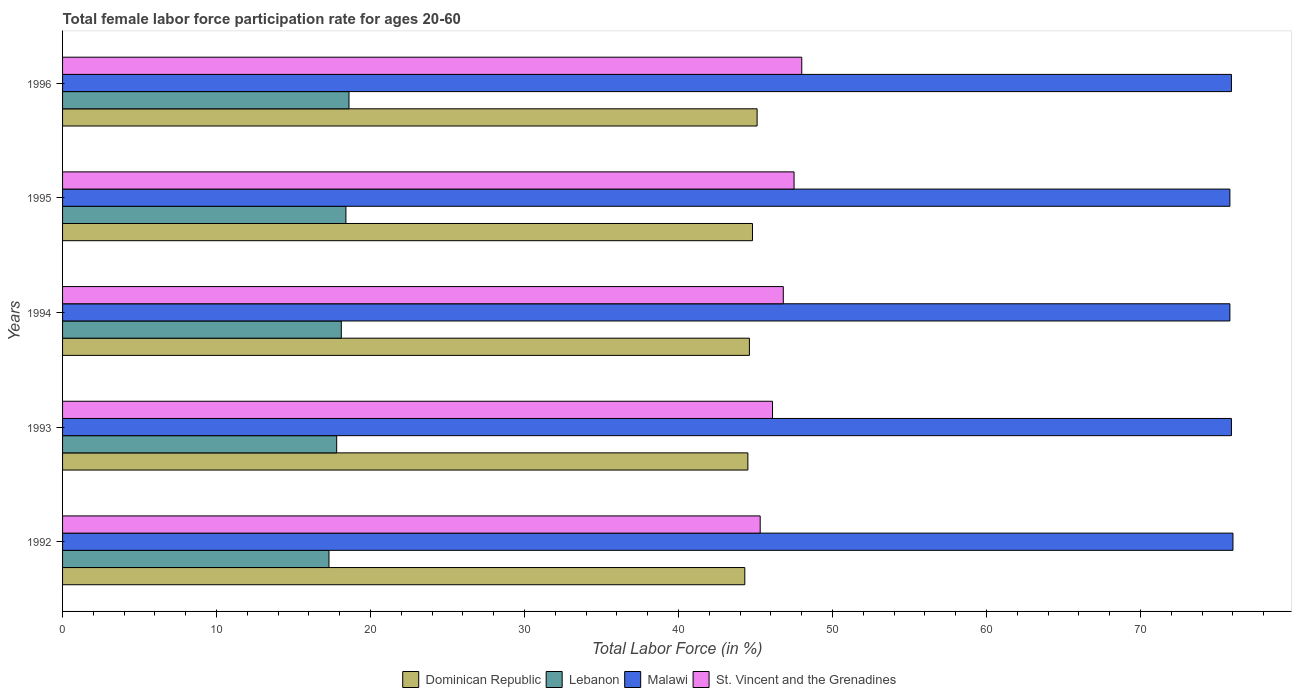How many different coloured bars are there?
Make the answer very short. 4. Are the number of bars per tick equal to the number of legend labels?
Your response must be concise. Yes. Are the number of bars on each tick of the Y-axis equal?
Provide a succinct answer. Yes. What is the label of the 5th group of bars from the top?
Your response must be concise. 1992. In how many cases, is the number of bars for a given year not equal to the number of legend labels?
Ensure brevity in your answer.  0. What is the female labor force participation rate in Dominican Republic in 1992?
Provide a succinct answer. 44.3. Across all years, what is the maximum female labor force participation rate in St. Vincent and the Grenadines?
Offer a terse response. 48. Across all years, what is the minimum female labor force participation rate in Dominican Republic?
Your response must be concise. 44.3. In which year was the female labor force participation rate in Malawi maximum?
Your answer should be very brief. 1992. In which year was the female labor force participation rate in St. Vincent and the Grenadines minimum?
Your answer should be very brief. 1992. What is the total female labor force participation rate in St. Vincent and the Grenadines in the graph?
Give a very brief answer. 233.7. What is the difference between the female labor force participation rate in Malawi in 1993 and that in 1995?
Your answer should be compact. 0.1. What is the difference between the female labor force participation rate in Malawi in 1993 and the female labor force participation rate in Lebanon in 1996?
Ensure brevity in your answer.  57.3. What is the average female labor force participation rate in Dominican Republic per year?
Ensure brevity in your answer.  44.66. In the year 1992, what is the difference between the female labor force participation rate in Lebanon and female labor force participation rate in St. Vincent and the Grenadines?
Ensure brevity in your answer.  -28. What is the ratio of the female labor force participation rate in Dominican Republic in 1994 to that in 1996?
Your answer should be very brief. 0.99. Is the female labor force participation rate in Dominican Republic in 1993 less than that in 1994?
Provide a succinct answer. Yes. What is the difference between the highest and the second highest female labor force participation rate in St. Vincent and the Grenadines?
Provide a succinct answer. 0.5. What is the difference between the highest and the lowest female labor force participation rate in Malawi?
Your answer should be very brief. 0.2. Is the sum of the female labor force participation rate in St. Vincent and the Grenadines in 1994 and 1995 greater than the maximum female labor force participation rate in Malawi across all years?
Give a very brief answer. Yes. Is it the case that in every year, the sum of the female labor force participation rate in St. Vincent and the Grenadines and female labor force participation rate in Dominican Republic is greater than the sum of female labor force participation rate in Malawi and female labor force participation rate in Lebanon?
Provide a short and direct response. No. What does the 1st bar from the top in 1994 represents?
Offer a very short reply. St. Vincent and the Grenadines. What does the 4th bar from the bottom in 1992 represents?
Make the answer very short. St. Vincent and the Grenadines. Is it the case that in every year, the sum of the female labor force participation rate in Dominican Republic and female labor force participation rate in Lebanon is greater than the female labor force participation rate in Malawi?
Your answer should be compact. No. How many bars are there?
Give a very brief answer. 20. Does the graph contain grids?
Provide a short and direct response. No. How are the legend labels stacked?
Your response must be concise. Horizontal. What is the title of the graph?
Ensure brevity in your answer.  Total female labor force participation rate for ages 20-60. Does "Ethiopia" appear as one of the legend labels in the graph?
Your answer should be compact. No. What is the label or title of the Y-axis?
Ensure brevity in your answer.  Years. What is the Total Labor Force (in %) of Dominican Republic in 1992?
Provide a short and direct response. 44.3. What is the Total Labor Force (in %) in Lebanon in 1992?
Your response must be concise. 17.3. What is the Total Labor Force (in %) of St. Vincent and the Grenadines in 1992?
Keep it short and to the point. 45.3. What is the Total Labor Force (in %) in Dominican Republic in 1993?
Provide a succinct answer. 44.5. What is the Total Labor Force (in %) in Lebanon in 1993?
Offer a very short reply. 17.8. What is the Total Labor Force (in %) of Malawi in 1993?
Your answer should be compact. 75.9. What is the Total Labor Force (in %) of St. Vincent and the Grenadines in 1993?
Offer a terse response. 46.1. What is the Total Labor Force (in %) in Dominican Republic in 1994?
Your response must be concise. 44.6. What is the Total Labor Force (in %) of Lebanon in 1994?
Provide a short and direct response. 18.1. What is the Total Labor Force (in %) of Malawi in 1994?
Offer a terse response. 75.8. What is the Total Labor Force (in %) of St. Vincent and the Grenadines in 1994?
Give a very brief answer. 46.8. What is the Total Labor Force (in %) in Dominican Republic in 1995?
Your response must be concise. 44.8. What is the Total Labor Force (in %) of Lebanon in 1995?
Keep it short and to the point. 18.4. What is the Total Labor Force (in %) in Malawi in 1995?
Your answer should be compact. 75.8. What is the Total Labor Force (in %) of St. Vincent and the Grenadines in 1995?
Your answer should be very brief. 47.5. What is the Total Labor Force (in %) of Dominican Republic in 1996?
Offer a terse response. 45.1. What is the Total Labor Force (in %) in Lebanon in 1996?
Provide a short and direct response. 18.6. What is the Total Labor Force (in %) in Malawi in 1996?
Your answer should be compact. 75.9. What is the Total Labor Force (in %) of St. Vincent and the Grenadines in 1996?
Provide a short and direct response. 48. Across all years, what is the maximum Total Labor Force (in %) in Dominican Republic?
Offer a terse response. 45.1. Across all years, what is the maximum Total Labor Force (in %) of Lebanon?
Your response must be concise. 18.6. Across all years, what is the maximum Total Labor Force (in %) of Malawi?
Ensure brevity in your answer.  76. Across all years, what is the maximum Total Labor Force (in %) in St. Vincent and the Grenadines?
Offer a very short reply. 48. Across all years, what is the minimum Total Labor Force (in %) in Dominican Republic?
Make the answer very short. 44.3. Across all years, what is the minimum Total Labor Force (in %) in Lebanon?
Your answer should be compact. 17.3. Across all years, what is the minimum Total Labor Force (in %) in Malawi?
Your response must be concise. 75.8. Across all years, what is the minimum Total Labor Force (in %) of St. Vincent and the Grenadines?
Your answer should be very brief. 45.3. What is the total Total Labor Force (in %) in Dominican Republic in the graph?
Provide a short and direct response. 223.3. What is the total Total Labor Force (in %) of Lebanon in the graph?
Offer a very short reply. 90.2. What is the total Total Labor Force (in %) of Malawi in the graph?
Your answer should be very brief. 379.4. What is the total Total Labor Force (in %) in St. Vincent and the Grenadines in the graph?
Your answer should be very brief. 233.7. What is the difference between the Total Labor Force (in %) of Dominican Republic in 1992 and that in 1993?
Make the answer very short. -0.2. What is the difference between the Total Labor Force (in %) in Malawi in 1992 and that in 1993?
Your answer should be very brief. 0.1. What is the difference between the Total Labor Force (in %) of Dominican Republic in 1992 and that in 1994?
Offer a very short reply. -0.3. What is the difference between the Total Labor Force (in %) in St. Vincent and the Grenadines in 1992 and that in 1994?
Give a very brief answer. -1.5. What is the difference between the Total Labor Force (in %) of Malawi in 1992 and that in 1995?
Give a very brief answer. 0.2. What is the difference between the Total Labor Force (in %) in St. Vincent and the Grenadines in 1992 and that in 1995?
Your answer should be compact. -2.2. What is the difference between the Total Labor Force (in %) in Lebanon in 1992 and that in 1996?
Your answer should be very brief. -1.3. What is the difference between the Total Labor Force (in %) in St. Vincent and the Grenadines in 1992 and that in 1996?
Keep it short and to the point. -2.7. What is the difference between the Total Labor Force (in %) of Malawi in 1993 and that in 1994?
Your response must be concise. 0.1. What is the difference between the Total Labor Force (in %) of Dominican Republic in 1993 and that in 1995?
Your response must be concise. -0.3. What is the difference between the Total Labor Force (in %) of St. Vincent and the Grenadines in 1993 and that in 1995?
Offer a terse response. -1.4. What is the difference between the Total Labor Force (in %) of Dominican Republic in 1993 and that in 1996?
Your answer should be compact. -0.6. What is the difference between the Total Labor Force (in %) in Lebanon in 1994 and that in 1995?
Keep it short and to the point. -0.3. What is the difference between the Total Labor Force (in %) in St. Vincent and the Grenadines in 1994 and that in 1995?
Give a very brief answer. -0.7. What is the difference between the Total Labor Force (in %) of St. Vincent and the Grenadines in 1994 and that in 1996?
Keep it short and to the point. -1.2. What is the difference between the Total Labor Force (in %) of Dominican Republic in 1992 and the Total Labor Force (in %) of Lebanon in 1993?
Provide a short and direct response. 26.5. What is the difference between the Total Labor Force (in %) in Dominican Republic in 1992 and the Total Labor Force (in %) in Malawi in 1993?
Offer a terse response. -31.6. What is the difference between the Total Labor Force (in %) of Lebanon in 1992 and the Total Labor Force (in %) of Malawi in 1993?
Provide a succinct answer. -58.6. What is the difference between the Total Labor Force (in %) in Lebanon in 1992 and the Total Labor Force (in %) in St. Vincent and the Grenadines in 1993?
Provide a succinct answer. -28.8. What is the difference between the Total Labor Force (in %) of Malawi in 1992 and the Total Labor Force (in %) of St. Vincent and the Grenadines in 1993?
Your answer should be very brief. 29.9. What is the difference between the Total Labor Force (in %) in Dominican Republic in 1992 and the Total Labor Force (in %) in Lebanon in 1994?
Provide a short and direct response. 26.2. What is the difference between the Total Labor Force (in %) in Dominican Republic in 1992 and the Total Labor Force (in %) in Malawi in 1994?
Make the answer very short. -31.5. What is the difference between the Total Labor Force (in %) of Lebanon in 1992 and the Total Labor Force (in %) of Malawi in 1994?
Provide a succinct answer. -58.5. What is the difference between the Total Labor Force (in %) of Lebanon in 1992 and the Total Labor Force (in %) of St. Vincent and the Grenadines in 1994?
Give a very brief answer. -29.5. What is the difference between the Total Labor Force (in %) in Malawi in 1992 and the Total Labor Force (in %) in St. Vincent and the Grenadines in 1994?
Ensure brevity in your answer.  29.2. What is the difference between the Total Labor Force (in %) of Dominican Republic in 1992 and the Total Labor Force (in %) of Lebanon in 1995?
Your answer should be very brief. 25.9. What is the difference between the Total Labor Force (in %) of Dominican Republic in 1992 and the Total Labor Force (in %) of Malawi in 1995?
Your response must be concise. -31.5. What is the difference between the Total Labor Force (in %) of Dominican Republic in 1992 and the Total Labor Force (in %) of St. Vincent and the Grenadines in 1995?
Ensure brevity in your answer.  -3.2. What is the difference between the Total Labor Force (in %) in Lebanon in 1992 and the Total Labor Force (in %) in Malawi in 1995?
Provide a short and direct response. -58.5. What is the difference between the Total Labor Force (in %) in Lebanon in 1992 and the Total Labor Force (in %) in St. Vincent and the Grenadines in 1995?
Keep it short and to the point. -30.2. What is the difference between the Total Labor Force (in %) of Dominican Republic in 1992 and the Total Labor Force (in %) of Lebanon in 1996?
Your answer should be compact. 25.7. What is the difference between the Total Labor Force (in %) in Dominican Republic in 1992 and the Total Labor Force (in %) in Malawi in 1996?
Keep it short and to the point. -31.6. What is the difference between the Total Labor Force (in %) of Lebanon in 1992 and the Total Labor Force (in %) of Malawi in 1996?
Ensure brevity in your answer.  -58.6. What is the difference between the Total Labor Force (in %) of Lebanon in 1992 and the Total Labor Force (in %) of St. Vincent and the Grenadines in 1996?
Give a very brief answer. -30.7. What is the difference between the Total Labor Force (in %) of Dominican Republic in 1993 and the Total Labor Force (in %) of Lebanon in 1994?
Give a very brief answer. 26.4. What is the difference between the Total Labor Force (in %) in Dominican Republic in 1993 and the Total Labor Force (in %) in Malawi in 1994?
Your answer should be compact. -31.3. What is the difference between the Total Labor Force (in %) in Lebanon in 1993 and the Total Labor Force (in %) in Malawi in 1994?
Your answer should be very brief. -58. What is the difference between the Total Labor Force (in %) in Lebanon in 1993 and the Total Labor Force (in %) in St. Vincent and the Grenadines in 1994?
Offer a terse response. -29. What is the difference between the Total Labor Force (in %) in Malawi in 1993 and the Total Labor Force (in %) in St. Vincent and the Grenadines in 1994?
Your answer should be very brief. 29.1. What is the difference between the Total Labor Force (in %) in Dominican Republic in 1993 and the Total Labor Force (in %) in Lebanon in 1995?
Ensure brevity in your answer.  26.1. What is the difference between the Total Labor Force (in %) of Dominican Republic in 1993 and the Total Labor Force (in %) of Malawi in 1995?
Give a very brief answer. -31.3. What is the difference between the Total Labor Force (in %) in Lebanon in 1993 and the Total Labor Force (in %) in Malawi in 1995?
Make the answer very short. -58. What is the difference between the Total Labor Force (in %) of Lebanon in 1993 and the Total Labor Force (in %) of St. Vincent and the Grenadines in 1995?
Provide a short and direct response. -29.7. What is the difference between the Total Labor Force (in %) in Malawi in 1993 and the Total Labor Force (in %) in St. Vincent and the Grenadines in 1995?
Offer a terse response. 28.4. What is the difference between the Total Labor Force (in %) in Dominican Republic in 1993 and the Total Labor Force (in %) in Lebanon in 1996?
Provide a short and direct response. 25.9. What is the difference between the Total Labor Force (in %) in Dominican Republic in 1993 and the Total Labor Force (in %) in Malawi in 1996?
Offer a very short reply. -31.4. What is the difference between the Total Labor Force (in %) of Lebanon in 1993 and the Total Labor Force (in %) of Malawi in 1996?
Your answer should be compact. -58.1. What is the difference between the Total Labor Force (in %) of Lebanon in 1993 and the Total Labor Force (in %) of St. Vincent and the Grenadines in 1996?
Your answer should be very brief. -30.2. What is the difference between the Total Labor Force (in %) of Malawi in 1993 and the Total Labor Force (in %) of St. Vincent and the Grenadines in 1996?
Provide a succinct answer. 27.9. What is the difference between the Total Labor Force (in %) of Dominican Republic in 1994 and the Total Labor Force (in %) of Lebanon in 1995?
Keep it short and to the point. 26.2. What is the difference between the Total Labor Force (in %) of Dominican Republic in 1994 and the Total Labor Force (in %) of Malawi in 1995?
Your answer should be compact. -31.2. What is the difference between the Total Labor Force (in %) in Lebanon in 1994 and the Total Labor Force (in %) in Malawi in 1995?
Ensure brevity in your answer.  -57.7. What is the difference between the Total Labor Force (in %) of Lebanon in 1994 and the Total Labor Force (in %) of St. Vincent and the Grenadines in 1995?
Provide a succinct answer. -29.4. What is the difference between the Total Labor Force (in %) in Malawi in 1994 and the Total Labor Force (in %) in St. Vincent and the Grenadines in 1995?
Your response must be concise. 28.3. What is the difference between the Total Labor Force (in %) in Dominican Republic in 1994 and the Total Labor Force (in %) in Malawi in 1996?
Keep it short and to the point. -31.3. What is the difference between the Total Labor Force (in %) of Dominican Republic in 1994 and the Total Labor Force (in %) of St. Vincent and the Grenadines in 1996?
Your answer should be compact. -3.4. What is the difference between the Total Labor Force (in %) of Lebanon in 1994 and the Total Labor Force (in %) of Malawi in 1996?
Your answer should be compact. -57.8. What is the difference between the Total Labor Force (in %) in Lebanon in 1994 and the Total Labor Force (in %) in St. Vincent and the Grenadines in 1996?
Make the answer very short. -29.9. What is the difference between the Total Labor Force (in %) in Malawi in 1994 and the Total Labor Force (in %) in St. Vincent and the Grenadines in 1996?
Keep it short and to the point. 27.8. What is the difference between the Total Labor Force (in %) in Dominican Republic in 1995 and the Total Labor Force (in %) in Lebanon in 1996?
Ensure brevity in your answer.  26.2. What is the difference between the Total Labor Force (in %) in Dominican Republic in 1995 and the Total Labor Force (in %) in Malawi in 1996?
Provide a succinct answer. -31.1. What is the difference between the Total Labor Force (in %) in Dominican Republic in 1995 and the Total Labor Force (in %) in St. Vincent and the Grenadines in 1996?
Provide a succinct answer. -3.2. What is the difference between the Total Labor Force (in %) in Lebanon in 1995 and the Total Labor Force (in %) in Malawi in 1996?
Your response must be concise. -57.5. What is the difference between the Total Labor Force (in %) in Lebanon in 1995 and the Total Labor Force (in %) in St. Vincent and the Grenadines in 1996?
Provide a succinct answer. -29.6. What is the difference between the Total Labor Force (in %) in Malawi in 1995 and the Total Labor Force (in %) in St. Vincent and the Grenadines in 1996?
Offer a terse response. 27.8. What is the average Total Labor Force (in %) in Dominican Republic per year?
Offer a very short reply. 44.66. What is the average Total Labor Force (in %) in Lebanon per year?
Provide a short and direct response. 18.04. What is the average Total Labor Force (in %) of Malawi per year?
Your response must be concise. 75.88. What is the average Total Labor Force (in %) in St. Vincent and the Grenadines per year?
Offer a terse response. 46.74. In the year 1992, what is the difference between the Total Labor Force (in %) of Dominican Republic and Total Labor Force (in %) of Malawi?
Your answer should be compact. -31.7. In the year 1992, what is the difference between the Total Labor Force (in %) in Dominican Republic and Total Labor Force (in %) in St. Vincent and the Grenadines?
Give a very brief answer. -1. In the year 1992, what is the difference between the Total Labor Force (in %) in Lebanon and Total Labor Force (in %) in Malawi?
Your answer should be very brief. -58.7. In the year 1992, what is the difference between the Total Labor Force (in %) of Lebanon and Total Labor Force (in %) of St. Vincent and the Grenadines?
Give a very brief answer. -28. In the year 1992, what is the difference between the Total Labor Force (in %) of Malawi and Total Labor Force (in %) of St. Vincent and the Grenadines?
Keep it short and to the point. 30.7. In the year 1993, what is the difference between the Total Labor Force (in %) in Dominican Republic and Total Labor Force (in %) in Lebanon?
Give a very brief answer. 26.7. In the year 1993, what is the difference between the Total Labor Force (in %) of Dominican Republic and Total Labor Force (in %) of Malawi?
Keep it short and to the point. -31.4. In the year 1993, what is the difference between the Total Labor Force (in %) in Dominican Republic and Total Labor Force (in %) in St. Vincent and the Grenadines?
Your response must be concise. -1.6. In the year 1993, what is the difference between the Total Labor Force (in %) in Lebanon and Total Labor Force (in %) in Malawi?
Your answer should be very brief. -58.1. In the year 1993, what is the difference between the Total Labor Force (in %) in Lebanon and Total Labor Force (in %) in St. Vincent and the Grenadines?
Keep it short and to the point. -28.3. In the year 1993, what is the difference between the Total Labor Force (in %) in Malawi and Total Labor Force (in %) in St. Vincent and the Grenadines?
Offer a very short reply. 29.8. In the year 1994, what is the difference between the Total Labor Force (in %) in Dominican Republic and Total Labor Force (in %) in Malawi?
Your response must be concise. -31.2. In the year 1994, what is the difference between the Total Labor Force (in %) in Dominican Republic and Total Labor Force (in %) in St. Vincent and the Grenadines?
Provide a short and direct response. -2.2. In the year 1994, what is the difference between the Total Labor Force (in %) of Lebanon and Total Labor Force (in %) of Malawi?
Your answer should be compact. -57.7. In the year 1994, what is the difference between the Total Labor Force (in %) of Lebanon and Total Labor Force (in %) of St. Vincent and the Grenadines?
Offer a terse response. -28.7. In the year 1995, what is the difference between the Total Labor Force (in %) in Dominican Republic and Total Labor Force (in %) in Lebanon?
Provide a succinct answer. 26.4. In the year 1995, what is the difference between the Total Labor Force (in %) in Dominican Republic and Total Labor Force (in %) in Malawi?
Give a very brief answer. -31. In the year 1995, what is the difference between the Total Labor Force (in %) of Dominican Republic and Total Labor Force (in %) of St. Vincent and the Grenadines?
Offer a very short reply. -2.7. In the year 1995, what is the difference between the Total Labor Force (in %) in Lebanon and Total Labor Force (in %) in Malawi?
Make the answer very short. -57.4. In the year 1995, what is the difference between the Total Labor Force (in %) of Lebanon and Total Labor Force (in %) of St. Vincent and the Grenadines?
Offer a terse response. -29.1. In the year 1995, what is the difference between the Total Labor Force (in %) of Malawi and Total Labor Force (in %) of St. Vincent and the Grenadines?
Your answer should be compact. 28.3. In the year 1996, what is the difference between the Total Labor Force (in %) of Dominican Republic and Total Labor Force (in %) of Malawi?
Make the answer very short. -30.8. In the year 1996, what is the difference between the Total Labor Force (in %) of Lebanon and Total Labor Force (in %) of Malawi?
Your answer should be very brief. -57.3. In the year 1996, what is the difference between the Total Labor Force (in %) of Lebanon and Total Labor Force (in %) of St. Vincent and the Grenadines?
Give a very brief answer. -29.4. In the year 1996, what is the difference between the Total Labor Force (in %) in Malawi and Total Labor Force (in %) in St. Vincent and the Grenadines?
Ensure brevity in your answer.  27.9. What is the ratio of the Total Labor Force (in %) in Lebanon in 1992 to that in 1993?
Keep it short and to the point. 0.97. What is the ratio of the Total Labor Force (in %) of St. Vincent and the Grenadines in 1992 to that in 1993?
Ensure brevity in your answer.  0.98. What is the ratio of the Total Labor Force (in %) of Lebanon in 1992 to that in 1994?
Offer a very short reply. 0.96. What is the ratio of the Total Labor Force (in %) of Malawi in 1992 to that in 1994?
Give a very brief answer. 1. What is the ratio of the Total Labor Force (in %) of St. Vincent and the Grenadines in 1992 to that in 1994?
Your answer should be compact. 0.97. What is the ratio of the Total Labor Force (in %) of Lebanon in 1992 to that in 1995?
Keep it short and to the point. 0.94. What is the ratio of the Total Labor Force (in %) in St. Vincent and the Grenadines in 1992 to that in 1995?
Keep it short and to the point. 0.95. What is the ratio of the Total Labor Force (in %) in Dominican Republic in 1992 to that in 1996?
Your answer should be very brief. 0.98. What is the ratio of the Total Labor Force (in %) in Lebanon in 1992 to that in 1996?
Ensure brevity in your answer.  0.93. What is the ratio of the Total Labor Force (in %) in Malawi in 1992 to that in 1996?
Offer a terse response. 1. What is the ratio of the Total Labor Force (in %) in St. Vincent and the Grenadines in 1992 to that in 1996?
Give a very brief answer. 0.94. What is the ratio of the Total Labor Force (in %) of Lebanon in 1993 to that in 1994?
Provide a succinct answer. 0.98. What is the ratio of the Total Labor Force (in %) in Malawi in 1993 to that in 1994?
Keep it short and to the point. 1. What is the ratio of the Total Labor Force (in %) in Lebanon in 1993 to that in 1995?
Your answer should be very brief. 0.97. What is the ratio of the Total Labor Force (in %) in St. Vincent and the Grenadines in 1993 to that in 1995?
Your response must be concise. 0.97. What is the ratio of the Total Labor Force (in %) in Dominican Republic in 1993 to that in 1996?
Give a very brief answer. 0.99. What is the ratio of the Total Labor Force (in %) in St. Vincent and the Grenadines in 1993 to that in 1996?
Keep it short and to the point. 0.96. What is the ratio of the Total Labor Force (in %) in Dominican Republic in 1994 to that in 1995?
Your answer should be very brief. 1. What is the ratio of the Total Labor Force (in %) in Lebanon in 1994 to that in 1995?
Make the answer very short. 0.98. What is the ratio of the Total Labor Force (in %) in Malawi in 1994 to that in 1995?
Your answer should be very brief. 1. What is the ratio of the Total Labor Force (in %) in St. Vincent and the Grenadines in 1994 to that in 1995?
Offer a very short reply. 0.99. What is the ratio of the Total Labor Force (in %) of Dominican Republic in 1994 to that in 1996?
Your answer should be compact. 0.99. What is the ratio of the Total Labor Force (in %) in Lebanon in 1994 to that in 1996?
Ensure brevity in your answer.  0.97. What is the ratio of the Total Labor Force (in %) of Malawi in 1994 to that in 1996?
Give a very brief answer. 1. What is the ratio of the Total Labor Force (in %) in St. Vincent and the Grenadines in 1994 to that in 1996?
Your answer should be compact. 0.97. What is the ratio of the Total Labor Force (in %) in Lebanon in 1995 to that in 1996?
Give a very brief answer. 0.99. What is the ratio of the Total Labor Force (in %) in Malawi in 1995 to that in 1996?
Your answer should be very brief. 1. What is the difference between the highest and the second highest Total Labor Force (in %) of Dominican Republic?
Make the answer very short. 0.3. What is the difference between the highest and the second highest Total Labor Force (in %) of Lebanon?
Provide a short and direct response. 0.2. What is the difference between the highest and the second highest Total Labor Force (in %) of St. Vincent and the Grenadines?
Provide a succinct answer. 0.5. What is the difference between the highest and the lowest Total Labor Force (in %) in Dominican Republic?
Provide a short and direct response. 0.8. What is the difference between the highest and the lowest Total Labor Force (in %) in Lebanon?
Provide a short and direct response. 1.3. What is the difference between the highest and the lowest Total Labor Force (in %) of Malawi?
Offer a very short reply. 0.2. 